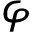Convert formula to latex. <formula><loc_0><loc_0><loc_500><loc_500>\varphi</formula> 